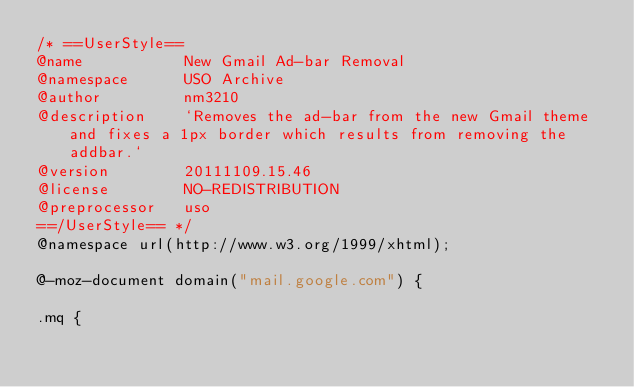<code> <loc_0><loc_0><loc_500><loc_500><_CSS_>/* ==UserStyle==
@name           New Gmail Ad-bar Removal
@namespace      USO Archive
@author         nm3210
@description    `Removes the ad-bar from the new Gmail theme and fixes a 1px border which results from removing the addbar.`
@version        20111109.15.46
@license        NO-REDISTRIBUTION
@preprocessor   uso
==/UserStyle== */
@namespace url(http://www.w3.org/1999/xhtml);

@-moz-document domain("mail.google.com") {

.mq {</code> 